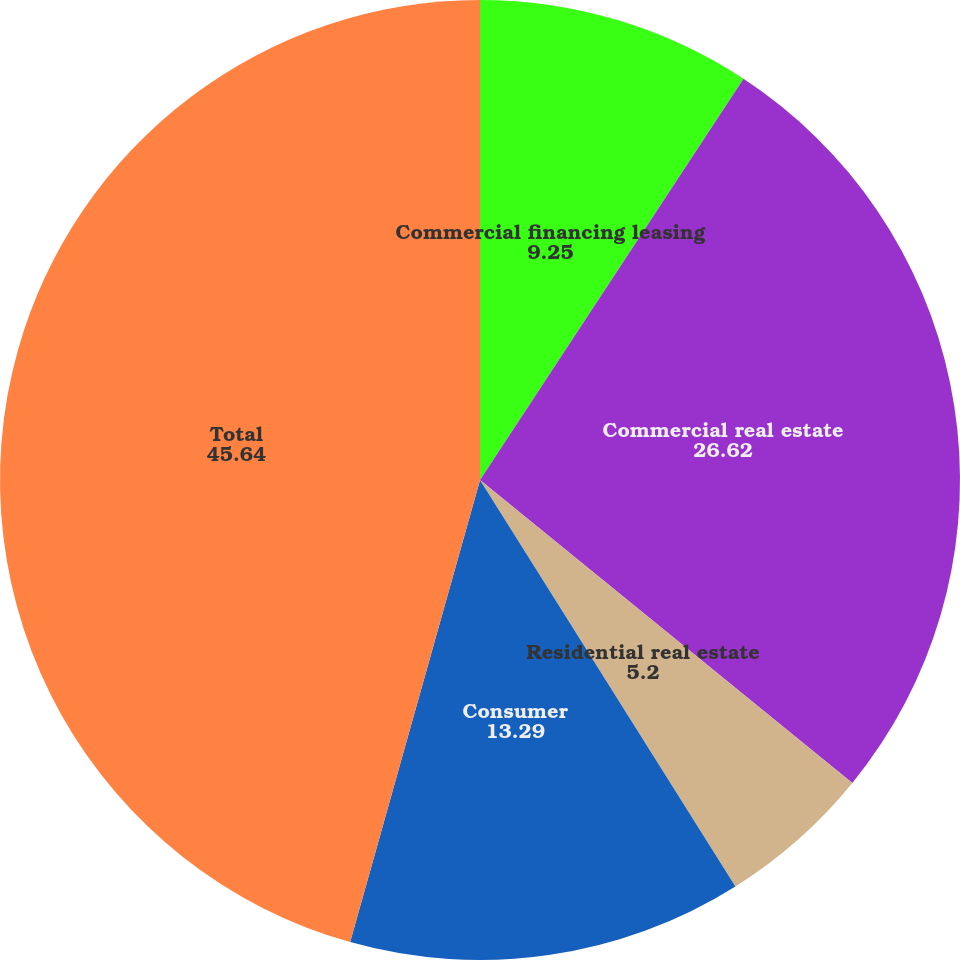Convert chart. <chart><loc_0><loc_0><loc_500><loc_500><pie_chart><fcel>Commercial financing leasing<fcel>Commercial real estate<fcel>Residential real estate<fcel>Consumer<fcel>Total<nl><fcel>9.25%<fcel>26.62%<fcel>5.2%<fcel>13.29%<fcel>45.64%<nl></chart> 